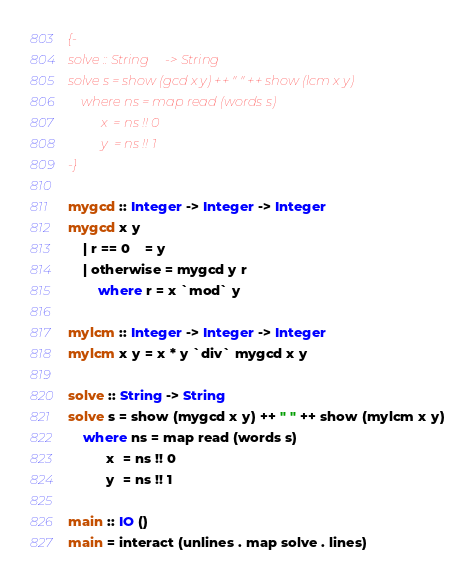Convert code to text. <code><loc_0><loc_0><loc_500><loc_500><_Haskell_>{-
solve :: String -> String
solve s = show (gcd x y) ++ " " ++ show (lcm x y)
    where ns = map read (words s)
          x  = ns !! 0
          y  = ns !! 1
-}

mygcd :: Integer -> Integer -> Integer
mygcd x y
    | r == 0    = y
    | otherwise = mygcd y r
        where r = x `mod` y

mylcm :: Integer -> Integer -> Integer
mylcm x y = x * y `div` mygcd x y

solve :: String -> String
solve s = show (mygcd x y) ++ " " ++ show (mylcm x y)
    where ns = map read (words s)
          x  = ns !! 0
          y  = ns !! 1

main :: IO ()
main = interact (unlines . map solve . lines)</code> 